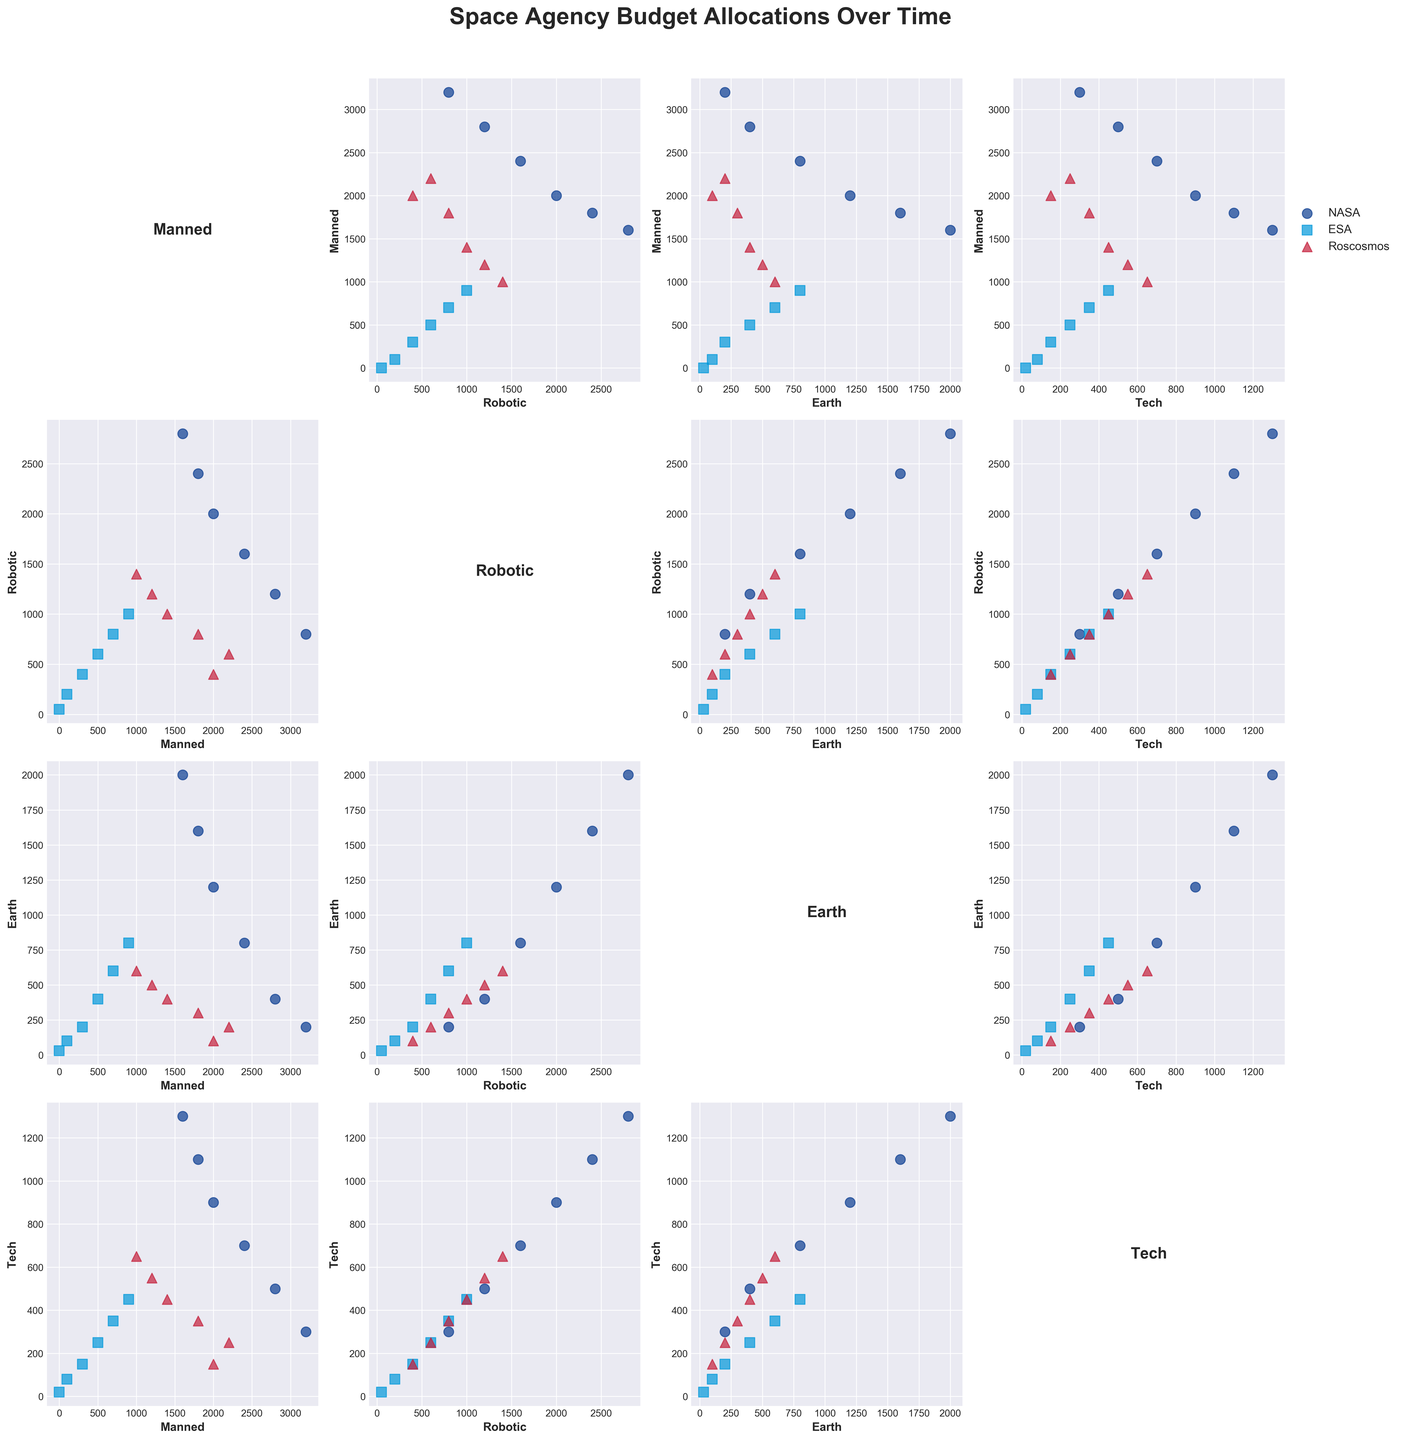Which year shows the highest budget allocation for NASA's robotic exploration? Look at the scatter points corresponding to NASA's robotic budget across different years. The year 2020 has the highest point on the y-axis in the robotics category for NASA.
Answer: 2020 How did ESA's budget for manned missions change from 1980 to 2020? Compare the scatter points corresponding to ESA's manned mission budget. In 1980, ESA allocated 100 units, and by 2020 this increased to 900 units.
Answer: Increased by 800 units Which agency allocated the highest budget for Earth observation in 2020? Compare the points on the y-axis under the Earth category for all three agencies in the year 2020. NASA's 2000 units for Earth observation are the highest.
Answer: NASA Is there a noticeable trend in the budget allocation for technology development by Roscosmos from 1970 to 2020? Observe the scatter points for Roscosmos' technology development budget over the years. The budget generally increased from 150 units in 1970 to 650 units in 2020.
Answer: Increasing trend Does NASA's budget for manned missions correlate with its budget for Earth observation? Check the scatterplot comparing NASA's manned missions (y-axis) against Earth observation (x-axis). The points are positively correlated; as the budget for Earth observation increases, so does the budget for manned missions.
Answer: Positive correlation Between 1970 and 2020, how did the budget for robotic exploration in ESA compare to that of NASA? Compare the scatter points for the robotic budget of ESA and NASA across the years. ESA's budget increases steadily but remains lower than NASA's, which sees more substantial growth.
Answer: NASA's budget is consistently higher Which category shows the most consistent budget allocation over time for Roscosmos? Compare the scatter plots for all categories and note the spread of points over the years. The Earth observation category shows relatively consistent allocation.
Answer: Earth observation What visual pattern do you notice when comparing technology development budgets across all three agencies? Look at the scatter points in the plots for technology development for NASA, ESA, and Roscosmos. All agencies show an increasing trend in budget allocation over time, with NASA leading, followed by ESA and Roscosmos.
Answer: Increasing trend for all agencies Do the scatter points for ESA's budget allocation in manned missions and technology development suggest any correlation? Examine the scatterplot for ESA's manned missions (y-axis) against technology development (x-axis). Points suggest a positive correlation; higher expenses in technology development accompany higher manned mission budgets.
Answer: Positive correlation 